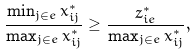<formula> <loc_0><loc_0><loc_500><loc_500>\frac { \min _ { j \in e } x ^ { * } _ { i j } } { \max _ { j \in e } x ^ { * } _ { i j } } \geq \frac { z ^ { * } _ { i e } } { \max _ { j \in e } x ^ { * } _ { i j } } ,</formula> 